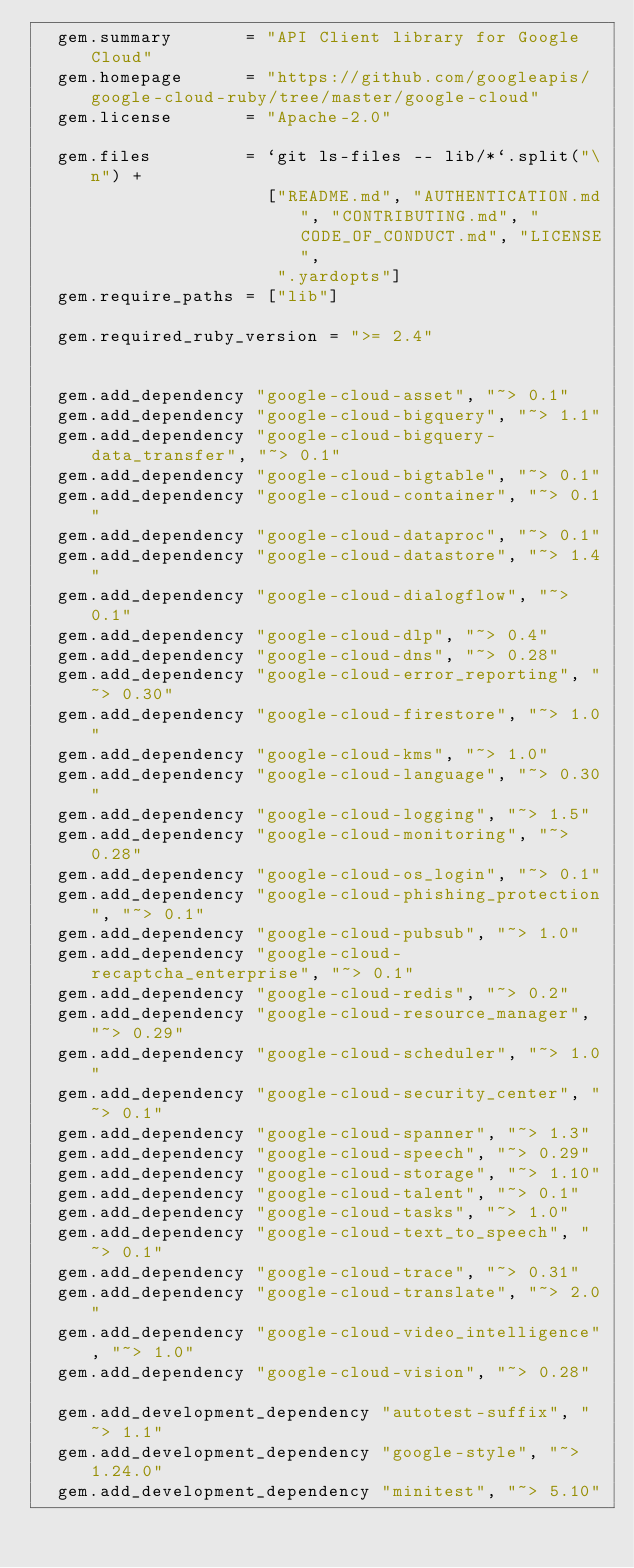Convert code to text. <code><loc_0><loc_0><loc_500><loc_500><_Ruby_>  gem.summary       = "API Client library for Google Cloud"
  gem.homepage      = "https://github.com/googleapis/google-cloud-ruby/tree/master/google-cloud"
  gem.license       = "Apache-2.0"

  gem.files         = `git ls-files -- lib/*`.split("\n") +
                      ["README.md", "AUTHENTICATION.md", "CONTRIBUTING.md", "CODE_OF_CONDUCT.md", "LICENSE",
                       ".yardopts"]
  gem.require_paths = ["lib"]

  gem.required_ruby_version = ">= 2.4"


  gem.add_dependency "google-cloud-asset", "~> 0.1"
  gem.add_dependency "google-cloud-bigquery", "~> 1.1"
  gem.add_dependency "google-cloud-bigquery-data_transfer", "~> 0.1"
  gem.add_dependency "google-cloud-bigtable", "~> 0.1"
  gem.add_dependency "google-cloud-container", "~> 0.1"
  gem.add_dependency "google-cloud-dataproc", "~> 0.1"
  gem.add_dependency "google-cloud-datastore", "~> 1.4"
  gem.add_dependency "google-cloud-dialogflow", "~> 0.1"
  gem.add_dependency "google-cloud-dlp", "~> 0.4"
  gem.add_dependency "google-cloud-dns", "~> 0.28"
  gem.add_dependency "google-cloud-error_reporting", "~> 0.30"
  gem.add_dependency "google-cloud-firestore", "~> 1.0"
  gem.add_dependency "google-cloud-kms", "~> 1.0"
  gem.add_dependency "google-cloud-language", "~> 0.30"
  gem.add_dependency "google-cloud-logging", "~> 1.5"
  gem.add_dependency "google-cloud-monitoring", "~> 0.28"
  gem.add_dependency "google-cloud-os_login", "~> 0.1"
  gem.add_dependency "google-cloud-phishing_protection", "~> 0.1"
  gem.add_dependency "google-cloud-pubsub", "~> 1.0"
  gem.add_dependency "google-cloud-recaptcha_enterprise", "~> 0.1"
  gem.add_dependency "google-cloud-redis", "~> 0.2"
  gem.add_dependency "google-cloud-resource_manager", "~> 0.29"
  gem.add_dependency "google-cloud-scheduler", "~> 1.0"
  gem.add_dependency "google-cloud-security_center", "~> 0.1"
  gem.add_dependency "google-cloud-spanner", "~> 1.3"
  gem.add_dependency "google-cloud-speech", "~> 0.29"
  gem.add_dependency "google-cloud-storage", "~> 1.10"
  gem.add_dependency "google-cloud-talent", "~> 0.1"
  gem.add_dependency "google-cloud-tasks", "~> 1.0"
  gem.add_dependency "google-cloud-text_to_speech", "~> 0.1"
  gem.add_dependency "google-cloud-trace", "~> 0.31"
  gem.add_dependency "google-cloud-translate", "~> 2.0"
  gem.add_dependency "google-cloud-video_intelligence", "~> 1.0"
  gem.add_dependency "google-cloud-vision", "~> 0.28"

  gem.add_development_dependency "autotest-suffix", "~> 1.1"
  gem.add_development_dependency "google-style", "~> 1.24.0"
  gem.add_development_dependency "minitest", "~> 5.10"</code> 